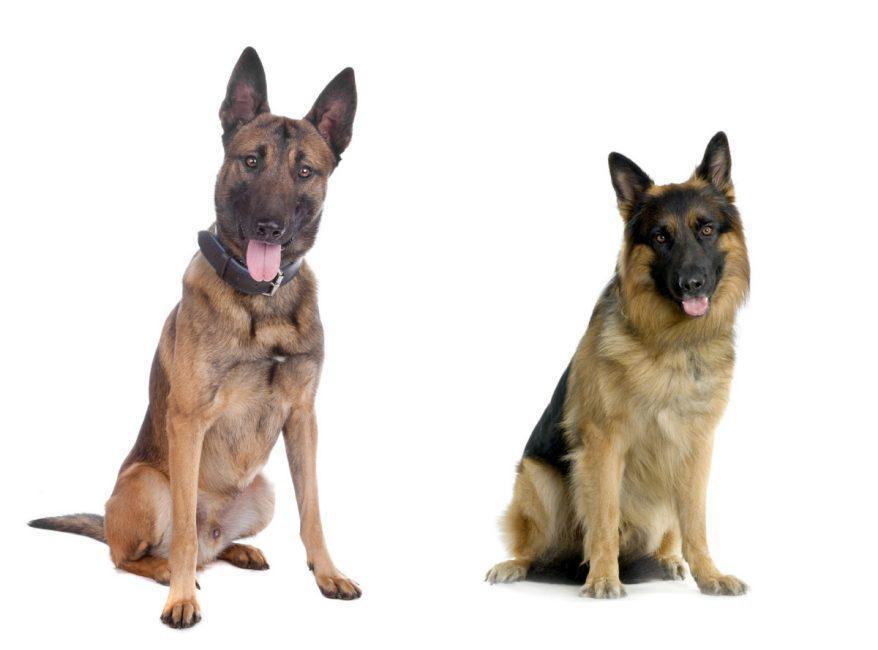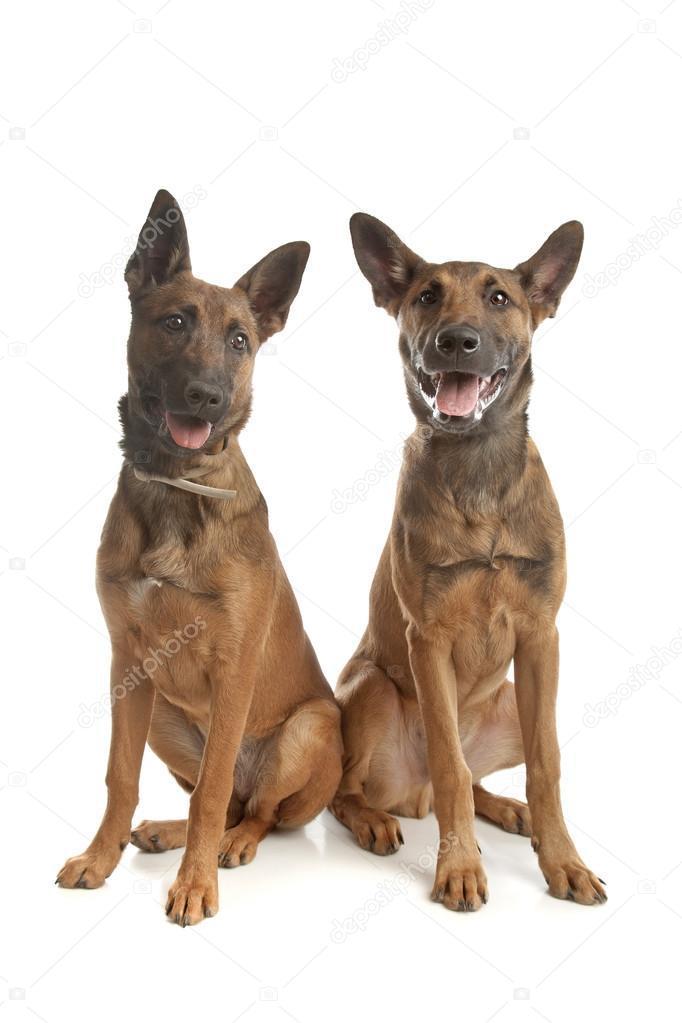The first image is the image on the left, the second image is the image on the right. For the images shown, is this caption "One of the images contains a dog touching a blue collar." true? Answer yes or no. No. The first image is the image on the left, the second image is the image on the right. Considering the images on both sides, is "An image shows one standing german shepherd facing leftward." valid? Answer yes or no. No. 